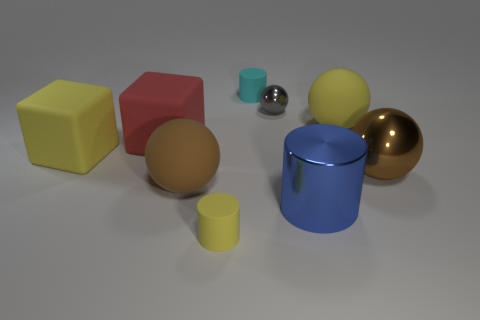What number of cylinders are blue metallic things or large yellow objects?
Your answer should be very brief. 1. There is a yellow matte object behind the yellow cube; is it the same shape as the blue metallic thing?
Provide a succinct answer. No. Is the number of yellow matte balls that are in front of the shiny cylinder greater than the number of tiny green shiny balls?
Keep it short and to the point. No. What is the color of the metal thing that is the same size as the metallic cylinder?
Your answer should be compact. Brown. How many objects are either big objects in front of the red rubber cube or small blue metal spheres?
Your answer should be very brief. 4. What material is the cylinder that is behind the large matte object that is right of the big brown rubber object?
Make the answer very short. Rubber. Is there a small gray cube that has the same material as the tiny cyan cylinder?
Make the answer very short. No. Is there a large brown metallic thing in front of the metal sphere to the right of the yellow sphere?
Provide a succinct answer. No. What is the tiny cylinder that is behind the big yellow rubber cube made of?
Keep it short and to the point. Rubber. Does the blue metal thing have the same shape as the gray thing?
Keep it short and to the point. No. 